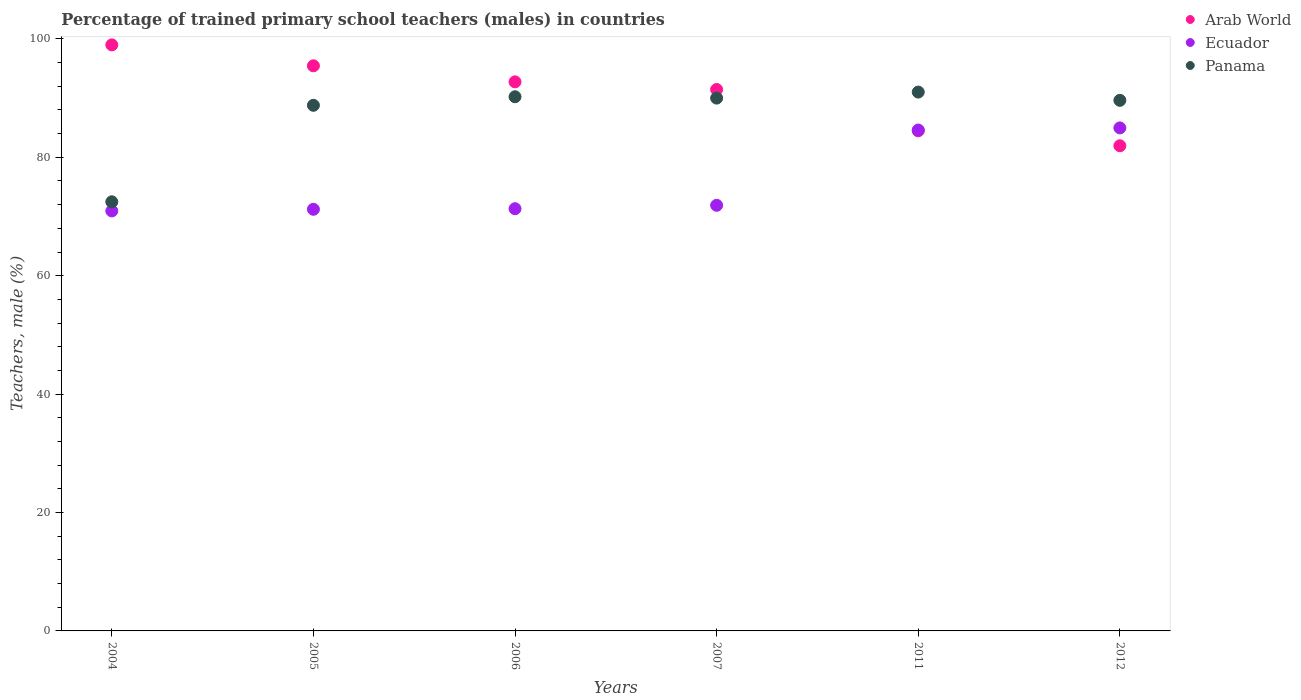Is the number of dotlines equal to the number of legend labels?
Provide a succinct answer. Yes. What is the percentage of trained primary school teachers (males) in Arab World in 2005?
Give a very brief answer. 95.45. Across all years, what is the maximum percentage of trained primary school teachers (males) in Ecuador?
Provide a succinct answer. 84.96. Across all years, what is the minimum percentage of trained primary school teachers (males) in Arab World?
Provide a succinct answer. 81.94. In which year was the percentage of trained primary school teachers (males) in Ecuador maximum?
Make the answer very short. 2012. What is the total percentage of trained primary school teachers (males) in Arab World in the graph?
Ensure brevity in your answer.  545.04. What is the difference between the percentage of trained primary school teachers (males) in Ecuador in 2005 and that in 2012?
Provide a short and direct response. -13.75. What is the difference between the percentage of trained primary school teachers (males) in Ecuador in 2006 and the percentage of trained primary school teachers (males) in Panama in 2007?
Give a very brief answer. -18.68. What is the average percentage of trained primary school teachers (males) in Panama per year?
Provide a succinct answer. 87.02. In the year 2005, what is the difference between the percentage of trained primary school teachers (males) in Ecuador and percentage of trained primary school teachers (males) in Arab World?
Make the answer very short. -24.24. What is the ratio of the percentage of trained primary school teachers (males) in Panama in 2004 to that in 2011?
Provide a short and direct response. 0.8. Is the percentage of trained primary school teachers (males) in Panama in 2004 less than that in 2005?
Give a very brief answer. Yes. What is the difference between the highest and the second highest percentage of trained primary school teachers (males) in Arab World?
Give a very brief answer. 3.53. What is the difference between the highest and the lowest percentage of trained primary school teachers (males) in Panama?
Ensure brevity in your answer.  18.53. Does the percentage of trained primary school teachers (males) in Panama monotonically increase over the years?
Make the answer very short. No. How many dotlines are there?
Your answer should be compact. 3. Are the values on the major ticks of Y-axis written in scientific E-notation?
Provide a short and direct response. No. Does the graph contain any zero values?
Ensure brevity in your answer.  No. Does the graph contain grids?
Make the answer very short. No. Where does the legend appear in the graph?
Make the answer very short. Top right. How many legend labels are there?
Provide a succinct answer. 3. How are the legend labels stacked?
Ensure brevity in your answer.  Vertical. What is the title of the graph?
Keep it short and to the point. Percentage of trained primary school teachers (males) in countries. Does "Zimbabwe" appear as one of the legend labels in the graph?
Ensure brevity in your answer.  No. What is the label or title of the Y-axis?
Ensure brevity in your answer.  Teachers, male (%). What is the Teachers, male (%) of Arab World in 2004?
Provide a short and direct response. 98.98. What is the Teachers, male (%) of Ecuador in 2004?
Provide a succinct answer. 70.94. What is the Teachers, male (%) of Panama in 2004?
Your response must be concise. 72.48. What is the Teachers, male (%) of Arab World in 2005?
Provide a succinct answer. 95.45. What is the Teachers, male (%) in Ecuador in 2005?
Your answer should be very brief. 71.21. What is the Teachers, male (%) in Panama in 2005?
Make the answer very short. 88.78. What is the Teachers, male (%) of Arab World in 2006?
Offer a terse response. 92.74. What is the Teachers, male (%) of Ecuador in 2006?
Offer a terse response. 71.31. What is the Teachers, male (%) in Panama in 2006?
Your answer should be compact. 90.22. What is the Teachers, male (%) of Arab World in 2007?
Ensure brevity in your answer.  91.45. What is the Teachers, male (%) of Ecuador in 2007?
Keep it short and to the point. 71.89. What is the Teachers, male (%) in Panama in 2007?
Offer a very short reply. 90. What is the Teachers, male (%) of Arab World in 2011?
Your response must be concise. 84.47. What is the Teachers, male (%) of Ecuador in 2011?
Ensure brevity in your answer.  84.6. What is the Teachers, male (%) of Panama in 2011?
Offer a terse response. 91.01. What is the Teachers, male (%) in Arab World in 2012?
Your answer should be very brief. 81.94. What is the Teachers, male (%) in Ecuador in 2012?
Your answer should be very brief. 84.96. What is the Teachers, male (%) in Panama in 2012?
Your answer should be compact. 89.62. Across all years, what is the maximum Teachers, male (%) of Arab World?
Make the answer very short. 98.98. Across all years, what is the maximum Teachers, male (%) of Ecuador?
Your answer should be compact. 84.96. Across all years, what is the maximum Teachers, male (%) of Panama?
Make the answer very short. 91.01. Across all years, what is the minimum Teachers, male (%) of Arab World?
Give a very brief answer. 81.94. Across all years, what is the minimum Teachers, male (%) of Ecuador?
Make the answer very short. 70.94. Across all years, what is the minimum Teachers, male (%) in Panama?
Provide a succinct answer. 72.48. What is the total Teachers, male (%) of Arab World in the graph?
Provide a short and direct response. 545.04. What is the total Teachers, male (%) of Ecuador in the graph?
Your answer should be very brief. 454.92. What is the total Teachers, male (%) in Panama in the graph?
Provide a succinct answer. 522.1. What is the difference between the Teachers, male (%) of Arab World in 2004 and that in 2005?
Provide a succinct answer. 3.54. What is the difference between the Teachers, male (%) of Ecuador in 2004 and that in 2005?
Your answer should be very brief. -0.28. What is the difference between the Teachers, male (%) of Panama in 2004 and that in 2005?
Your answer should be very brief. -16.3. What is the difference between the Teachers, male (%) in Arab World in 2004 and that in 2006?
Offer a very short reply. 6.25. What is the difference between the Teachers, male (%) in Ecuador in 2004 and that in 2006?
Your answer should be very brief. -0.37. What is the difference between the Teachers, male (%) in Panama in 2004 and that in 2006?
Give a very brief answer. -17.74. What is the difference between the Teachers, male (%) in Arab World in 2004 and that in 2007?
Your answer should be very brief. 7.54. What is the difference between the Teachers, male (%) in Ecuador in 2004 and that in 2007?
Ensure brevity in your answer.  -0.95. What is the difference between the Teachers, male (%) of Panama in 2004 and that in 2007?
Your answer should be compact. -17.52. What is the difference between the Teachers, male (%) of Arab World in 2004 and that in 2011?
Give a very brief answer. 14.51. What is the difference between the Teachers, male (%) of Ecuador in 2004 and that in 2011?
Provide a succinct answer. -13.66. What is the difference between the Teachers, male (%) in Panama in 2004 and that in 2011?
Your answer should be very brief. -18.53. What is the difference between the Teachers, male (%) of Arab World in 2004 and that in 2012?
Offer a very short reply. 17.04. What is the difference between the Teachers, male (%) of Ecuador in 2004 and that in 2012?
Your answer should be very brief. -14.02. What is the difference between the Teachers, male (%) of Panama in 2004 and that in 2012?
Keep it short and to the point. -17.14. What is the difference between the Teachers, male (%) of Arab World in 2005 and that in 2006?
Your response must be concise. 2.71. What is the difference between the Teachers, male (%) in Ecuador in 2005 and that in 2006?
Make the answer very short. -0.1. What is the difference between the Teachers, male (%) in Panama in 2005 and that in 2006?
Offer a terse response. -1.44. What is the difference between the Teachers, male (%) of Arab World in 2005 and that in 2007?
Ensure brevity in your answer.  4. What is the difference between the Teachers, male (%) of Ecuador in 2005 and that in 2007?
Give a very brief answer. -0.68. What is the difference between the Teachers, male (%) of Panama in 2005 and that in 2007?
Offer a terse response. -1.22. What is the difference between the Teachers, male (%) of Arab World in 2005 and that in 2011?
Offer a very short reply. 10.98. What is the difference between the Teachers, male (%) in Ecuador in 2005 and that in 2011?
Your answer should be very brief. -13.39. What is the difference between the Teachers, male (%) of Panama in 2005 and that in 2011?
Offer a terse response. -2.24. What is the difference between the Teachers, male (%) in Arab World in 2005 and that in 2012?
Ensure brevity in your answer.  13.51. What is the difference between the Teachers, male (%) in Ecuador in 2005 and that in 2012?
Keep it short and to the point. -13.75. What is the difference between the Teachers, male (%) of Panama in 2005 and that in 2012?
Make the answer very short. -0.84. What is the difference between the Teachers, male (%) in Arab World in 2006 and that in 2007?
Offer a very short reply. 1.29. What is the difference between the Teachers, male (%) of Ecuador in 2006 and that in 2007?
Your answer should be compact. -0.58. What is the difference between the Teachers, male (%) in Panama in 2006 and that in 2007?
Make the answer very short. 0.23. What is the difference between the Teachers, male (%) in Arab World in 2006 and that in 2011?
Give a very brief answer. 8.26. What is the difference between the Teachers, male (%) in Ecuador in 2006 and that in 2011?
Offer a terse response. -13.29. What is the difference between the Teachers, male (%) of Panama in 2006 and that in 2011?
Make the answer very short. -0.79. What is the difference between the Teachers, male (%) in Arab World in 2006 and that in 2012?
Your answer should be very brief. 10.79. What is the difference between the Teachers, male (%) in Ecuador in 2006 and that in 2012?
Your response must be concise. -13.65. What is the difference between the Teachers, male (%) in Panama in 2006 and that in 2012?
Provide a short and direct response. 0.6. What is the difference between the Teachers, male (%) in Arab World in 2007 and that in 2011?
Your response must be concise. 6.97. What is the difference between the Teachers, male (%) in Ecuador in 2007 and that in 2011?
Your answer should be very brief. -12.71. What is the difference between the Teachers, male (%) of Panama in 2007 and that in 2011?
Provide a succinct answer. -1.02. What is the difference between the Teachers, male (%) of Arab World in 2007 and that in 2012?
Give a very brief answer. 9.5. What is the difference between the Teachers, male (%) in Ecuador in 2007 and that in 2012?
Give a very brief answer. -13.07. What is the difference between the Teachers, male (%) of Panama in 2007 and that in 2012?
Provide a short and direct response. 0.38. What is the difference between the Teachers, male (%) of Arab World in 2011 and that in 2012?
Make the answer very short. 2.53. What is the difference between the Teachers, male (%) of Ecuador in 2011 and that in 2012?
Offer a very short reply. -0.36. What is the difference between the Teachers, male (%) of Panama in 2011 and that in 2012?
Make the answer very short. 1.4. What is the difference between the Teachers, male (%) in Arab World in 2004 and the Teachers, male (%) in Ecuador in 2005?
Offer a very short reply. 27.77. What is the difference between the Teachers, male (%) in Arab World in 2004 and the Teachers, male (%) in Panama in 2005?
Keep it short and to the point. 10.21. What is the difference between the Teachers, male (%) of Ecuador in 2004 and the Teachers, male (%) of Panama in 2005?
Offer a terse response. -17.84. What is the difference between the Teachers, male (%) in Arab World in 2004 and the Teachers, male (%) in Ecuador in 2006?
Provide a short and direct response. 27.67. What is the difference between the Teachers, male (%) of Arab World in 2004 and the Teachers, male (%) of Panama in 2006?
Give a very brief answer. 8.76. What is the difference between the Teachers, male (%) of Ecuador in 2004 and the Teachers, male (%) of Panama in 2006?
Provide a short and direct response. -19.28. What is the difference between the Teachers, male (%) in Arab World in 2004 and the Teachers, male (%) in Ecuador in 2007?
Give a very brief answer. 27.09. What is the difference between the Teachers, male (%) in Arab World in 2004 and the Teachers, male (%) in Panama in 2007?
Your answer should be compact. 8.99. What is the difference between the Teachers, male (%) in Ecuador in 2004 and the Teachers, male (%) in Panama in 2007?
Ensure brevity in your answer.  -19.06. What is the difference between the Teachers, male (%) of Arab World in 2004 and the Teachers, male (%) of Ecuador in 2011?
Your response must be concise. 14.39. What is the difference between the Teachers, male (%) of Arab World in 2004 and the Teachers, male (%) of Panama in 2011?
Offer a very short reply. 7.97. What is the difference between the Teachers, male (%) of Ecuador in 2004 and the Teachers, male (%) of Panama in 2011?
Your answer should be compact. -20.08. What is the difference between the Teachers, male (%) in Arab World in 2004 and the Teachers, male (%) in Ecuador in 2012?
Keep it short and to the point. 14.02. What is the difference between the Teachers, male (%) in Arab World in 2004 and the Teachers, male (%) in Panama in 2012?
Provide a short and direct response. 9.37. What is the difference between the Teachers, male (%) of Ecuador in 2004 and the Teachers, male (%) of Panama in 2012?
Your answer should be very brief. -18.68. What is the difference between the Teachers, male (%) of Arab World in 2005 and the Teachers, male (%) of Ecuador in 2006?
Ensure brevity in your answer.  24.14. What is the difference between the Teachers, male (%) in Arab World in 2005 and the Teachers, male (%) in Panama in 2006?
Provide a succinct answer. 5.23. What is the difference between the Teachers, male (%) of Ecuador in 2005 and the Teachers, male (%) of Panama in 2006?
Your response must be concise. -19.01. What is the difference between the Teachers, male (%) of Arab World in 2005 and the Teachers, male (%) of Ecuador in 2007?
Give a very brief answer. 23.56. What is the difference between the Teachers, male (%) of Arab World in 2005 and the Teachers, male (%) of Panama in 2007?
Your answer should be very brief. 5.45. What is the difference between the Teachers, male (%) in Ecuador in 2005 and the Teachers, male (%) in Panama in 2007?
Give a very brief answer. -18.78. What is the difference between the Teachers, male (%) of Arab World in 2005 and the Teachers, male (%) of Ecuador in 2011?
Provide a succinct answer. 10.85. What is the difference between the Teachers, male (%) in Arab World in 2005 and the Teachers, male (%) in Panama in 2011?
Provide a short and direct response. 4.44. What is the difference between the Teachers, male (%) in Ecuador in 2005 and the Teachers, male (%) in Panama in 2011?
Offer a very short reply. -19.8. What is the difference between the Teachers, male (%) in Arab World in 2005 and the Teachers, male (%) in Ecuador in 2012?
Provide a short and direct response. 10.49. What is the difference between the Teachers, male (%) of Arab World in 2005 and the Teachers, male (%) of Panama in 2012?
Your answer should be very brief. 5.83. What is the difference between the Teachers, male (%) in Ecuador in 2005 and the Teachers, male (%) in Panama in 2012?
Ensure brevity in your answer.  -18.4. What is the difference between the Teachers, male (%) of Arab World in 2006 and the Teachers, male (%) of Ecuador in 2007?
Keep it short and to the point. 20.85. What is the difference between the Teachers, male (%) in Arab World in 2006 and the Teachers, male (%) in Panama in 2007?
Make the answer very short. 2.74. What is the difference between the Teachers, male (%) of Ecuador in 2006 and the Teachers, male (%) of Panama in 2007?
Provide a succinct answer. -18.68. What is the difference between the Teachers, male (%) in Arab World in 2006 and the Teachers, male (%) in Ecuador in 2011?
Your response must be concise. 8.14. What is the difference between the Teachers, male (%) in Arab World in 2006 and the Teachers, male (%) in Panama in 2011?
Your response must be concise. 1.72. What is the difference between the Teachers, male (%) in Ecuador in 2006 and the Teachers, male (%) in Panama in 2011?
Provide a succinct answer. -19.7. What is the difference between the Teachers, male (%) of Arab World in 2006 and the Teachers, male (%) of Ecuador in 2012?
Keep it short and to the point. 7.78. What is the difference between the Teachers, male (%) of Arab World in 2006 and the Teachers, male (%) of Panama in 2012?
Your answer should be compact. 3.12. What is the difference between the Teachers, male (%) in Ecuador in 2006 and the Teachers, male (%) in Panama in 2012?
Make the answer very short. -18.3. What is the difference between the Teachers, male (%) of Arab World in 2007 and the Teachers, male (%) of Ecuador in 2011?
Ensure brevity in your answer.  6.85. What is the difference between the Teachers, male (%) in Arab World in 2007 and the Teachers, male (%) in Panama in 2011?
Your response must be concise. 0.43. What is the difference between the Teachers, male (%) of Ecuador in 2007 and the Teachers, male (%) of Panama in 2011?
Offer a very short reply. -19.12. What is the difference between the Teachers, male (%) in Arab World in 2007 and the Teachers, male (%) in Ecuador in 2012?
Offer a very short reply. 6.49. What is the difference between the Teachers, male (%) in Arab World in 2007 and the Teachers, male (%) in Panama in 2012?
Provide a short and direct response. 1.83. What is the difference between the Teachers, male (%) of Ecuador in 2007 and the Teachers, male (%) of Panama in 2012?
Provide a succinct answer. -17.73. What is the difference between the Teachers, male (%) in Arab World in 2011 and the Teachers, male (%) in Ecuador in 2012?
Ensure brevity in your answer.  -0.49. What is the difference between the Teachers, male (%) of Arab World in 2011 and the Teachers, male (%) of Panama in 2012?
Offer a terse response. -5.14. What is the difference between the Teachers, male (%) in Ecuador in 2011 and the Teachers, male (%) in Panama in 2012?
Ensure brevity in your answer.  -5.02. What is the average Teachers, male (%) in Arab World per year?
Keep it short and to the point. 90.84. What is the average Teachers, male (%) in Ecuador per year?
Give a very brief answer. 75.82. What is the average Teachers, male (%) of Panama per year?
Your answer should be very brief. 87.02. In the year 2004, what is the difference between the Teachers, male (%) in Arab World and Teachers, male (%) in Ecuador?
Provide a short and direct response. 28.05. In the year 2004, what is the difference between the Teachers, male (%) of Arab World and Teachers, male (%) of Panama?
Offer a terse response. 26.51. In the year 2004, what is the difference between the Teachers, male (%) in Ecuador and Teachers, male (%) in Panama?
Your answer should be very brief. -1.54. In the year 2005, what is the difference between the Teachers, male (%) in Arab World and Teachers, male (%) in Ecuador?
Keep it short and to the point. 24.24. In the year 2005, what is the difference between the Teachers, male (%) in Arab World and Teachers, male (%) in Panama?
Provide a short and direct response. 6.67. In the year 2005, what is the difference between the Teachers, male (%) in Ecuador and Teachers, male (%) in Panama?
Give a very brief answer. -17.56. In the year 2006, what is the difference between the Teachers, male (%) of Arab World and Teachers, male (%) of Ecuador?
Provide a short and direct response. 21.43. In the year 2006, what is the difference between the Teachers, male (%) of Arab World and Teachers, male (%) of Panama?
Your answer should be very brief. 2.52. In the year 2006, what is the difference between the Teachers, male (%) in Ecuador and Teachers, male (%) in Panama?
Offer a very short reply. -18.91. In the year 2007, what is the difference between the Teachers, male (%) of Arab World and Teachers, male (%) of Ecuador?
Provide a short and direct response. 19.56. In the year 2007, what is the difference between the Teachers, male (%) in Arab World and Teachers, male (%) in Panama?
Your answer should be very brief. 1.45. In the year 2007, what is the difference between the Teachers, male (%) in Ecuador and Teachers, male (%) in Panama?
Provide a succinct answer. -18.11. In the year 2011, what is the difference between the Teachers, male (%) in Arab World and Teachers, male (%) in Ecuador?
Give a very brief answer. -0.12. In the year 2011, what is the difference between the Teachers, male (%) of Arab World and Teachers, male (%) of Panama?
Your answer should be very brief. -6.54. In the year 2011, what is the difference between the Teachers, male (%) in Ecuador and Teachers, male (%) in Panama?
Provide a short and direct response. -6.42. In the year 2012, what is the difference between the Teachers, male (%) of Arab World and Teachers, male (%) of Ecuador?
Your response must be concise. -3.02. In the year 2012, what is the difference between the Teachers, male (%) in Arab World and Teachers, male (%) in Panama?
Your answer should be very brief. -7.67. In the year 2012, what is the difference between the Teachers, male (%) in Ecuador and Teachers, male (%) in Panama?
Make the answer very short. -4.65. What is the ratio of the Teachers, male (%) in Arab World in 2004 to that in 2005?
Your response must be concise. 1.04. What is the ratio of the Teachers, male (%) of Panama in 2004 to that in 2005?
Ensure brevity in your answer.  0.82. What is the ratio of the Teachers, male (%) in Arab World in 2004 to that in 2006?
Give a very brief answer. 1.07. What is the ratio of the Teachers, male (%) in Ecuador in 2004 to that in 2006?
Give a very brief answer. 0.99. What is the ratio of the Teachers, male (%) of Panama in 2004 to that in 2006?
Your answer should be compact. 0.8. What is the ratio of the Teachers, male (%) in Arab World in 2004 to that in 2007?
Your answer should be compact. 1.08. What is the ratio of the Teachers, male (%) of Ecuador in 2004 to that in 2007?
Give a very brief answer. 0.99. What is the ratio of the Teachers, male (%) in Panama in 2004 to that in 2007?
Offer a very short reply. 0.81. What is the ratio of the Teachers, male (%) in Arab World in 2004 to that in 2011?
Offer a terse response. 1.17. What is the ratio of the Teachers, male (%) in Ecuador in 2004 to that in 2011?
Offer a terse response. 0.84. What is the ratio of the Teachers, male (%) of Panama in 2004 to that in 2011?
Make the answer very short. 0.8. What is the ratio of the Teachers, male (%) in Arab World in 2004 to that in 2012?
Ensure brevity in your answer.  1.21. What is the ratio of the Teachers, male (%) in Ecuador in 2004 to that in 2012?
Offer a very short reply. 0.83. What is the ratio of the Teachers, male (%) in Panama in 2004 to that in 2012?
Keep it short and to the point. 0.81. What is the ratio of the Teachers, male (%) of Arab World in 2005 to that in 2006?
Your answer should be very brief. 1.03. What is the ratio of the Teachers, male (%) in Ecuador in 2005 to that in 2006?
Provide a succinct answer. 1. What is the ratio of the Teachers, male (%) in Panama in 2005 to that in 2006?
Give a very brief answer. 0.98. What is the ratio of the Teachers, male (%) in Arab World in 2005 to that in 2007?
Make the answer very short. 1.04. What is the ratio of the Teachers, male (%) in Ecuador in 2005 to that in 2007?
Your answer should be very brief. 0.99. What is the ratio of the Teachers, male (%) of Panama in 2005 to that in 2007?
Make the answer very short. 0.99. What is the ratio of the Teachers, male (%) in Arab World in 2005 to that in 2011?
Make the answer very short. 1.13. What is the ratio of the Teachers, male (%) of Ecuador in 2005 to that in 2011?
Ensure brevity in your answer.  0.84. What is the ratio of the Teachers, male (%) of Panama in 2005 to that in 2011?
Ensure brevity in your answer.  0.98. What is the ratio of the Teachers, male (%) of Arab World in 2005 to that in 2012?
Your answer should be compact. 1.16. What is the ratio of the Teachers, male (%) in Ecuador in 2005 to that in 2012?
Your answer should be compact. 0.84. What is the ratio of the Teachers, male (%) in Panama in 2005 to that in 2012?
Ensure brevity in your answer.  0.99. What is the ratio of the Teachers, male (%) in Arab World in 2006 to that in 2007?
Offer a very short reply. 1.01. What is the ratio of the Teachers, male (%) of Ecuador in 2006 to that in 2007?
Your response must be concise. 0.99. What is the ratio of the Teachers, male (%) of Panama in 2006 to that in 2007?
Ensure brevity in your answer.  1. What is the ratio of the Teachers, male (%) of Arab World in 2006 to that in 2011?
Keep it short and to the point. 1.1. What is the ratio of the Teachers, male (%) of Ecuador in 2006 to that in 2011?
Give a very brief answer. 0.84. What is the ratio of the Teachers, male (%) of Panama in 2006 to that in 2011?
Provide a succinct answer. 0.99. What is the ratio of the Teachers, male (%) of Arab World in 2006 to that in 2012?
Make the answer very short. 1.13. What is the ratio of the Teachers, male (%) in Ecuador in 2006 to that in 2012?
Keep it short and to the point. 0.84. What is the ratio of the Teachers, male (%) in Panama in 2006 to that in 2012?
Your response must be concise. 1.01. What is the ratio of the Teachers, male (%) of Arab World in 2007 to that in 2011?
Provide a succinct answer. 1.08. What is the ratio of the Teachers, male (%) of Ecuador in 2007 to that in 2011?
Make the answer very short. 0.85. What is the ratio of the Teachers, male (%) in Arab World in 2007 to that in 2012?
Your response must be concise. 1.12. What is the ratio of the Teachers, male (%) of Ecuador in 2007 to that in 2012?
Give a very brief answer. 0.85. What is the ratio of the Teachers, male (%) in Panama in 2007 to that in 2012?
Make the answer very short. 1. What is the ratio of the Teachers, male (%) of Arab World in 2011 to that in 2012?
Ensure brevity in your answer.  1.03. What is the ratio of the Teachers, male (%) of Panama in 2011 to that in 2012?
Ensure brevity in your answer.  1.02. What is the difference between the highest and the second highest Teachers, male (%) of Arab World?
Provide a succinct answer. 3.54. What is the difference between the highest and the second highest Teachers, male (%) of Ecuador?
Provide a short and direct response. 0.36. What is the difference between the highest and the second highest Teachers, male (%) of Panama?
Offer a terse response. 0.79. What is the difference between the highest and the lowest Teachers, male (%) of Arab World?
Your answer should be compact. 17.04. What is the difference between the highest and the lowest Teachers, male (%) of Ecuador?
Your response must be concise. 14.02. What is the difference between the highest and the lowest Teachers, male (%) in Panama?
Your response must be concise. 18.53. 